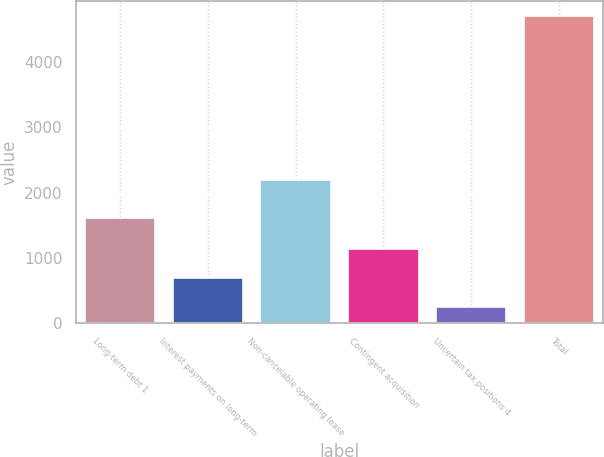<chart> <loc_0><loc_0><loc_500><loc_500><bar_chart><fcel>Long-term debt 1<fcel>Interest payments on long-term<fcel>Non-cancelable operating lease<fcel>Contingent acquisition<fcel>Uncertain tax positions 4<fcel>Total<nl><fcel>1604.6<fcel>692.67<fcel>2192.1<fcel>1138.64<fcel>246.7<fcel>4706.4<nl></chart> 